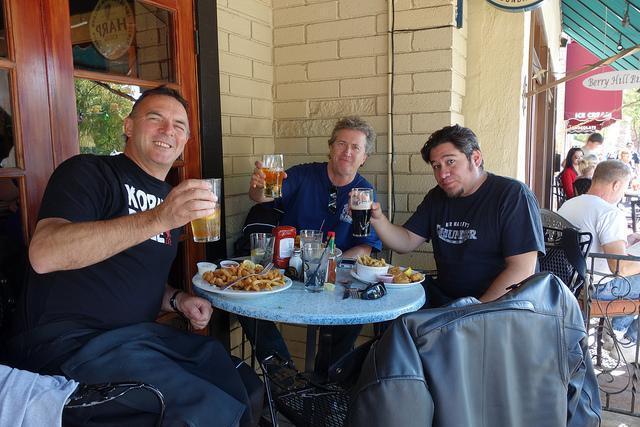How many chairs are in the picture?
Give a very brief answer. 3. How many people are there?
Give a very brief answer. 4. 